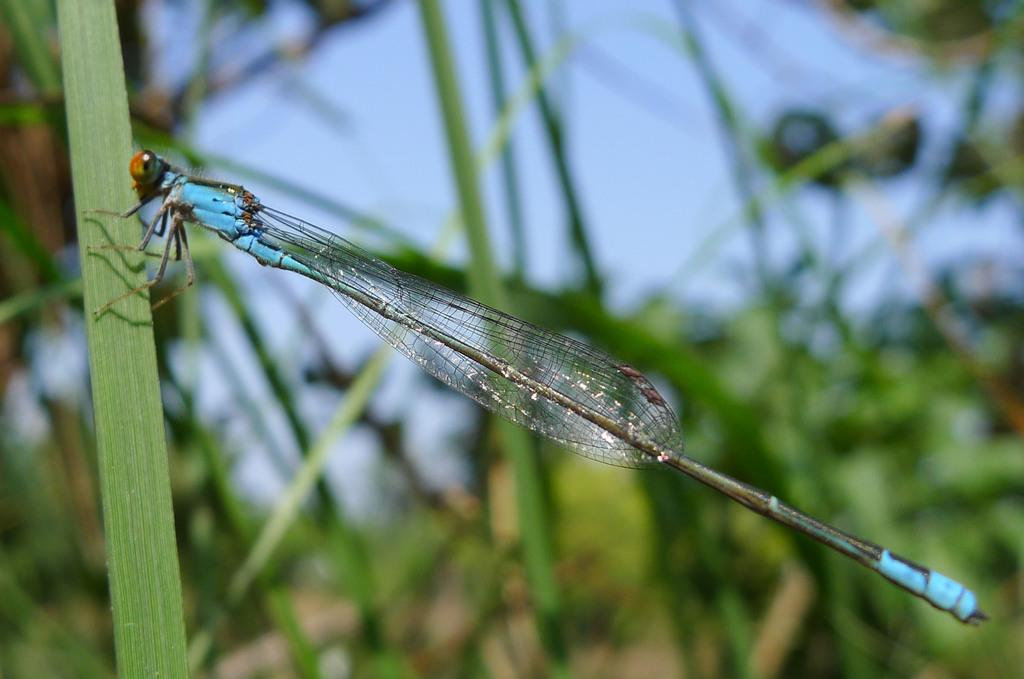What type of creature is in the image? There is an insect in the image. What is the insect standing on? The insect is on green grass. What colors can be seen in the background of the image? The background of the image is green and blue. What shape is the partner of the insect in the image? There is no partner of the insect present in the image. How does the sponge help the insect in the image? There is no sponge present in the image, so it cannot help the insect. 